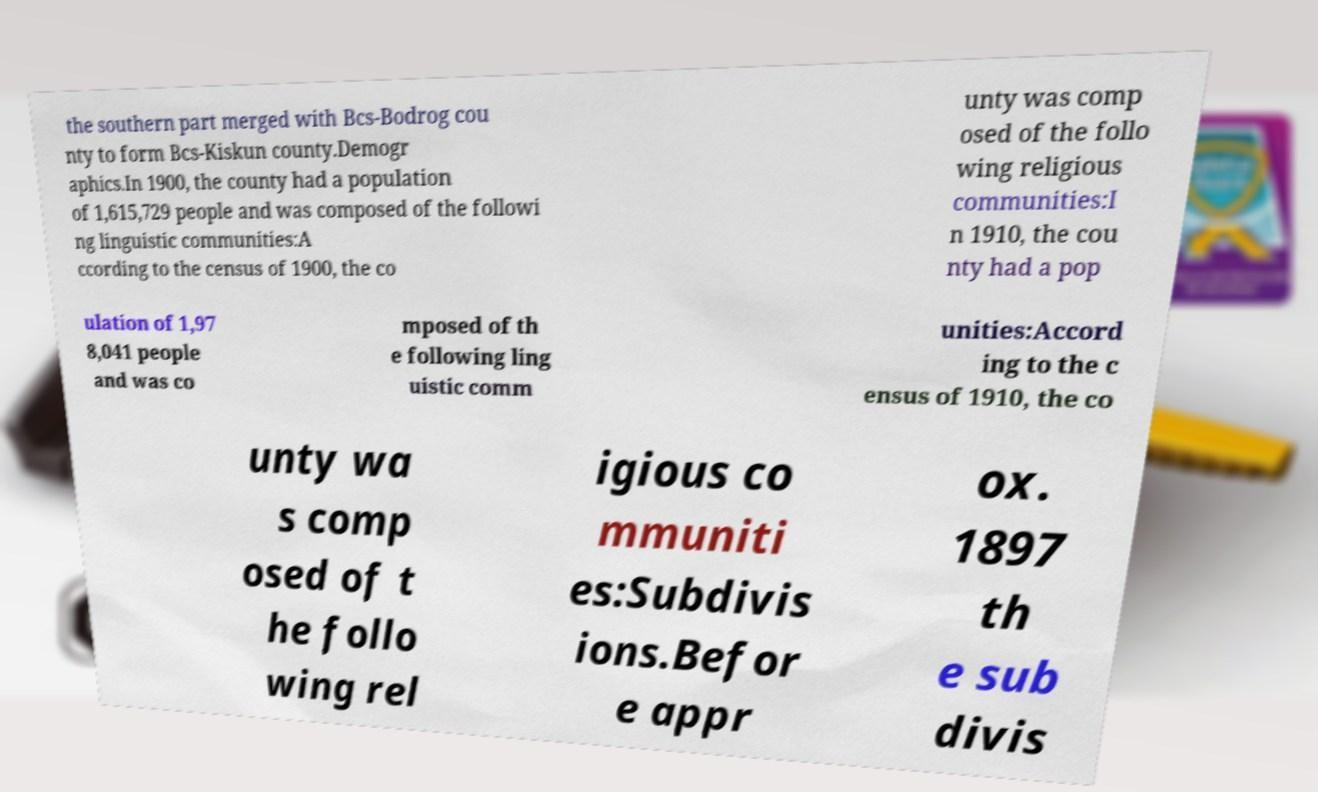Can you accurately transcribe the text from the provided image for me? the southern part merged with Bcs-Bodrog cou nty to form Bcs-Kiskun county.Demogr aphics.In 1900, the county had a population of 1,615,729 people and was composed of the followi ng linguistic communities:A ccording to the census of 1900, the co unty was comp osed of the follo wing religious communities:I n 1910, the cou nty had a pop ulation of 1,97 8,041 people and was co mposed of th e following ling uistic comm unities:Accord ing to the c ensus of 1910, the co unty wa s comp osed of t he follo wing rel igious co mmuniti es:Subdivis ions.Befor e appr ox. 1897 th e sub divis 